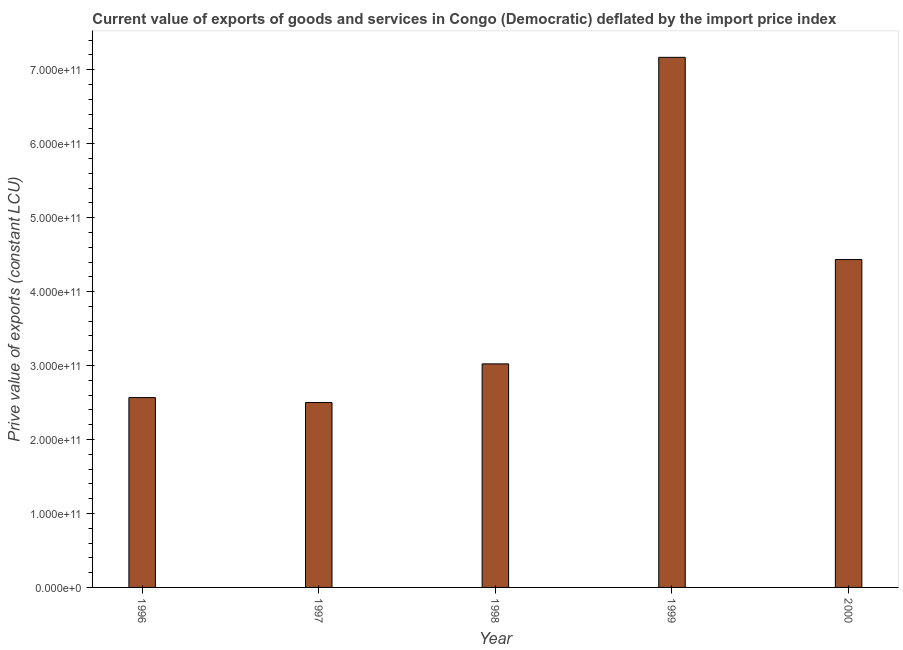What is the title of the graph?
Your answer should be compact. Current value of exports of goods and services in Congo (Democratic) deflated by the import price index. What is the label or title of the Y-axis?
Give a very brief answer. Prive value of exports (constant LCU). What is the price value of exports in 1999?
Your response must be concise. 7.17e+11. Across all years, what is the maximum price value of exports?
Ensure brevity in your answer.  7.17e+11. Across all years, what is the minimum price value of exports?
Your answer should be very brief. 2.50e+11. In which year was the price value of exports minimum?
Offer a very short reply. 1997. What is the sum of the price value of exports?
Offer a very short reply. 1.97e+12. What is the difference between the price value of exports in 1997 and 1999?
Make the answer very short. -4.67e+11. What is the average price value of exports per year?
Make the answer very short. 3.94e+11. What is the median price value of exports?
Keep it short and to the point. 3.02e+11. In how many years, is the price value of exports greater than 660000000000 LCU?
Make the answer very short. 1. Do a majority of the years between 1997 and 1996 (inclusive) have price value of exports greater than 120000000000 LCU?
Provide a short and direct response. No. What is the ratio of the price value of exports in 1996 to that in 1998?
Provide a short and direct response. 0.85. What is the difference between the highest and the second highest price value of exports?
Offer a very short reply. 2.73e+11. What is the difference between the highest and the lowest price value of exports?
Provide a short and direct response. 4.67e+11. Are all the bars in the graph horizontal?
Make the answer very short. No. How many years are there in the graph?
Your answer should be very brief. 5. What is the difference between two consecutive major ticks on the Y-axis?
Provide a succinct answer. 1.00e+11. Are the values on the major ticks of Y-axis written in scientific E-notation?
Offer a terse response. Yes. What is the Prive value of exports (constant LCU) in 1996?
Offer a very short reply. 2.57e+11. What is the Prive value of exports (constant LCU) of 1997?
Offer a terse response. 2.50e+11. What is the Prive value of exports (constant LCU) in 1998?
Keep it short and to the point. 3.02e+11. What is the Prive value of exports (constant LCU) of 1999?
Provide a short and direct response. 7.17e+11. What is the Prive value of exports (constant LCU) in 2000?
Ensure brevity in your answer.  4.43e+11. What is the difference between the Prive value of exports (constant LCU) in 1996 and 1997?
Give a very brief answer. 6.71e+09. What is the difference between the Prive value of exports (constant LCU) in 1996 and 1998?
Make the answer very short. -4.56e+1. What is the difference between the Prive value of exports (constant LCU) in 1996 and 1999?
Your answer should be very brief. -4.60e+11. What is the difference between the Prive value of exports (constant LCU) in 1996 and 2000?
Ensure brevity in your answer.  -1.87e+11. What is the difference between the Prive value of exports (constant LCU) in 1997 and 1998?
Your answer should be very brief. -5.23e+1. What is the difference between the Prive value of exports (constant LCU) in 1997 and 1999?
Your answer should be compact. -4.67e+11. What is the difference between the Prive value of exports (constant LCU) in 1997 and 2000?
Offer a terse response. -1.93e+11. What is the difference between the Prive value of exports (constant LCU) in 1998 and 1999?
Your answer should be compact. -4.15e+11. What is the difference between the Prive value of exports (constant LCU) in 1998 and 2000?
Provide a succinct answer. -1.41e+11. What is the difference between the Prive value of exports (constant LCU) in 1999 and 2000?
Your answer should be compact. 2.73e+11. What is the ratio of the Prive value of exports (constant LCU) in 1996 to that in 1998?
Make the answer very short. 0.85. What is the ratio of the Prive value of exports (constant LCU) in 1996 to that in 1999?
Provide a short and direct response. 0.36. What is the ratio of the Prive value of exports (constant LCU) in 1996 to that in 2000?
Provide a short and direct response. 0.58. What is the ratio of the Prive value of exports (constant LCU) in 1997 to that in 1998?
Your response must be concise. 0.83. What is the ratio of the Prive value of exports (constant LCU) in 1997 to that in 1999?
Offer a very short reply. 0.35. What is the ratio of the Prive value of exports (constant LCU) in 1997 to that in 2000?
Give a very brief answer. 0.56. What is the ratio of the Prive value of exports (constant LCU) in 1998 to that in 1999?
Provide a succinct answer. 0.42. What is the ratio of the Prive value of exports (constant LCU) in 1998 to that in 2000?
Offer a very short reply. 0.68. What is the ratio of the Prive value of exports (constant LCU) in 1999 to that in 2000?
Your response must be concise. 1.62. 